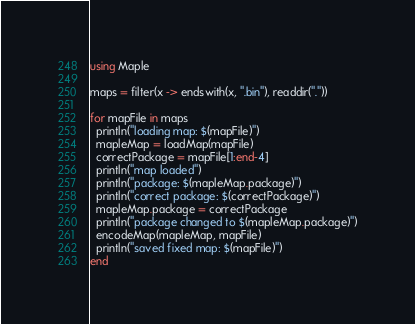Convert code to text. <code><loc_0><loc_0><loc_500><loc_500><_Julia_>using Maple

maps = filter(x -> endswith(x, ".bin"), readdir("."))

for mapFile in maps
  println("loading map: $(mapFile)")
  mapleMap = loadMap(mapFile)
  correctPackage = mapFile[1:end-4]
  println("map loaded") 
  println("package: $(mapleMap.package)")
  println("correct package: $(correctPackage)")
  mapleMap.package = correctPackage
  println("package changed to $(mapleMap.package)")
  encodeMap(mapleMap, mapFile)
  println("saved fixed map: $(mapFile)")
end
</code> 